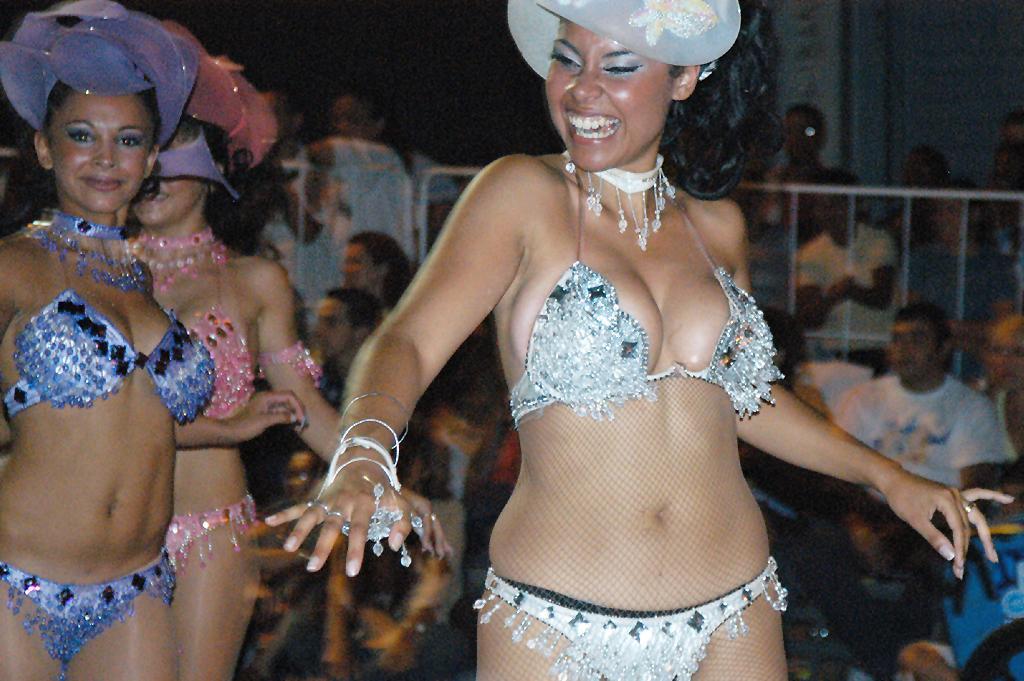Can you describe this image briefly? In the image there are three women dancing, they are wearing different clothes and behind the women, the crowd is watching their performance. 